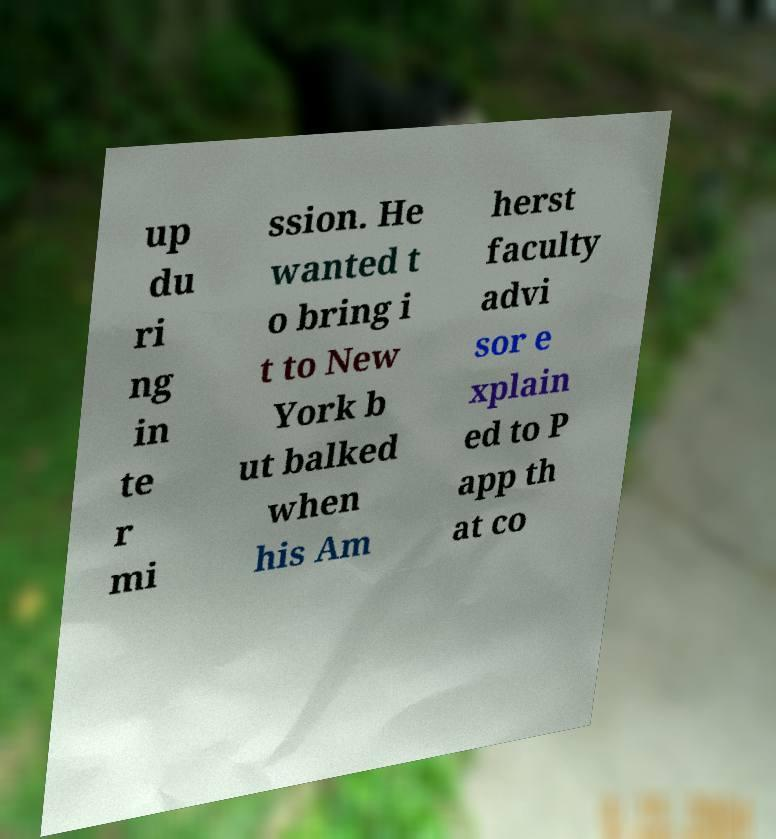Could you extract and type out the text from this image? up du ri ng in te r mi ssion. He wanted t o bring i t to New York b ut balked when his Am herst faculty advi sor e xplain ed to P app th at co 